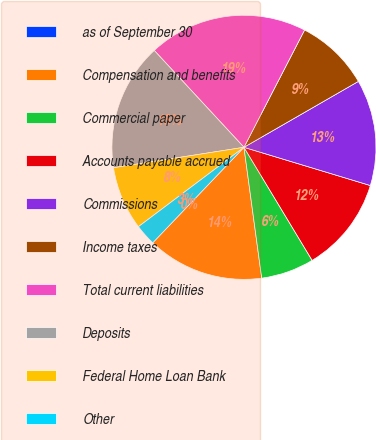Convert chart. <chart><loc_0><loc_0><loc_500><loc_500><pie_chart><fcel>as of September 30<fcel>Compensation and benefits<fcel>Commercial paper<fcel>Accounts payable accrued<fcel>Commissions<fcel>Income taxes<fcel>Total current liabilities<fcel>Deposits<fcel>Federal Home Loan Bank<fcel>Other<nl><fcel>0.0%<fcel>14.28%<fcel>6.49%<fcel>11.69%<fcel>12.99%<fcel>9.09%<fcel>19.48%<fcel>15.58%<fcel>7.79%<fcel>2.6%<nl></chart> 